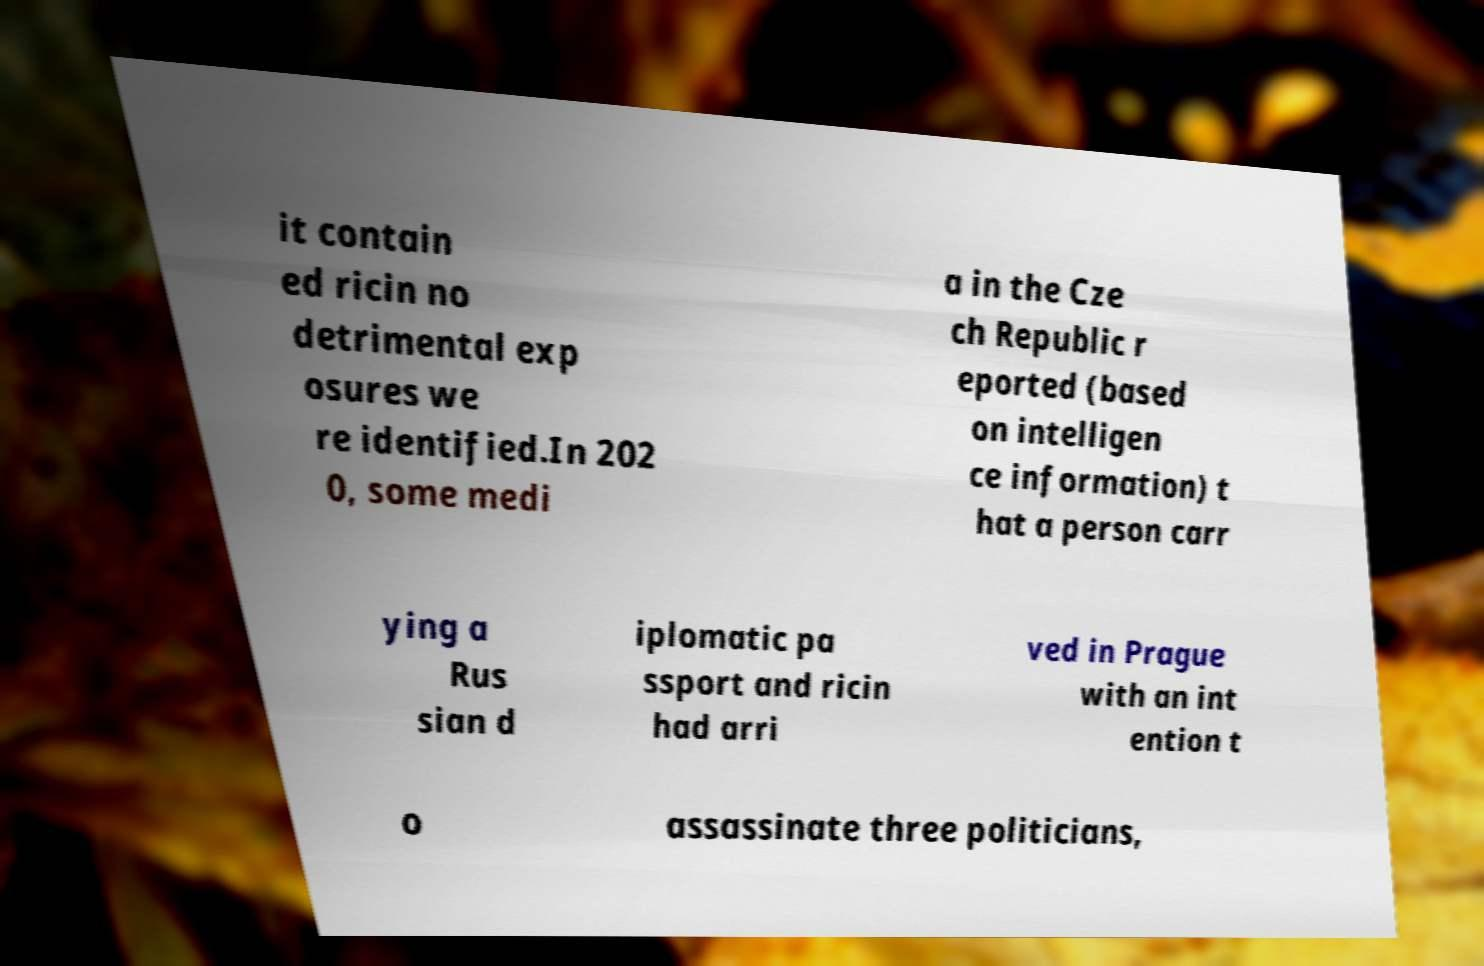For documentation purposes, I need the text within this image transcribed. Could you provide that? it contain ed ricin no detrimental exp osures we re identified.In 202 0, some medi a in the Cze ch Republic r eported (based on intelligen ce information) t hat a person carr ying a Rus sian d iplomatic pa ssport and ricin had arri ved in Prague with an int ention t o assassinate three politicians, 